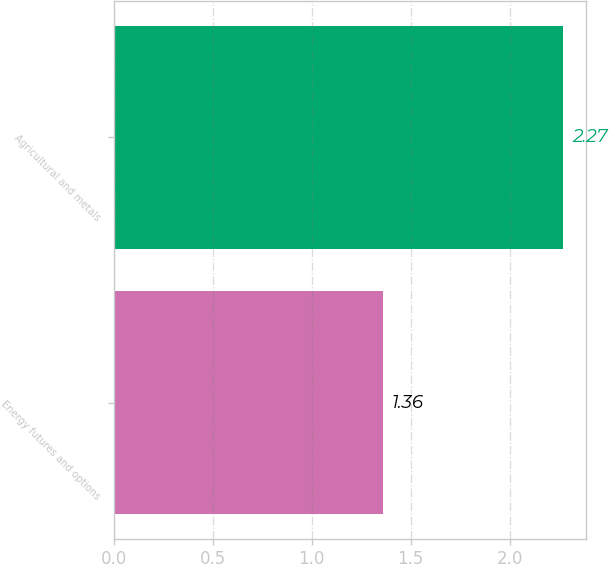<chart> <loc_0><loc_0><loc_500><loc_500><bar_chart><fcel>Energy futures and options<fcel>Agricultural and metals<nl><fcel>1.36<fcel>2.27<nl></chart> 